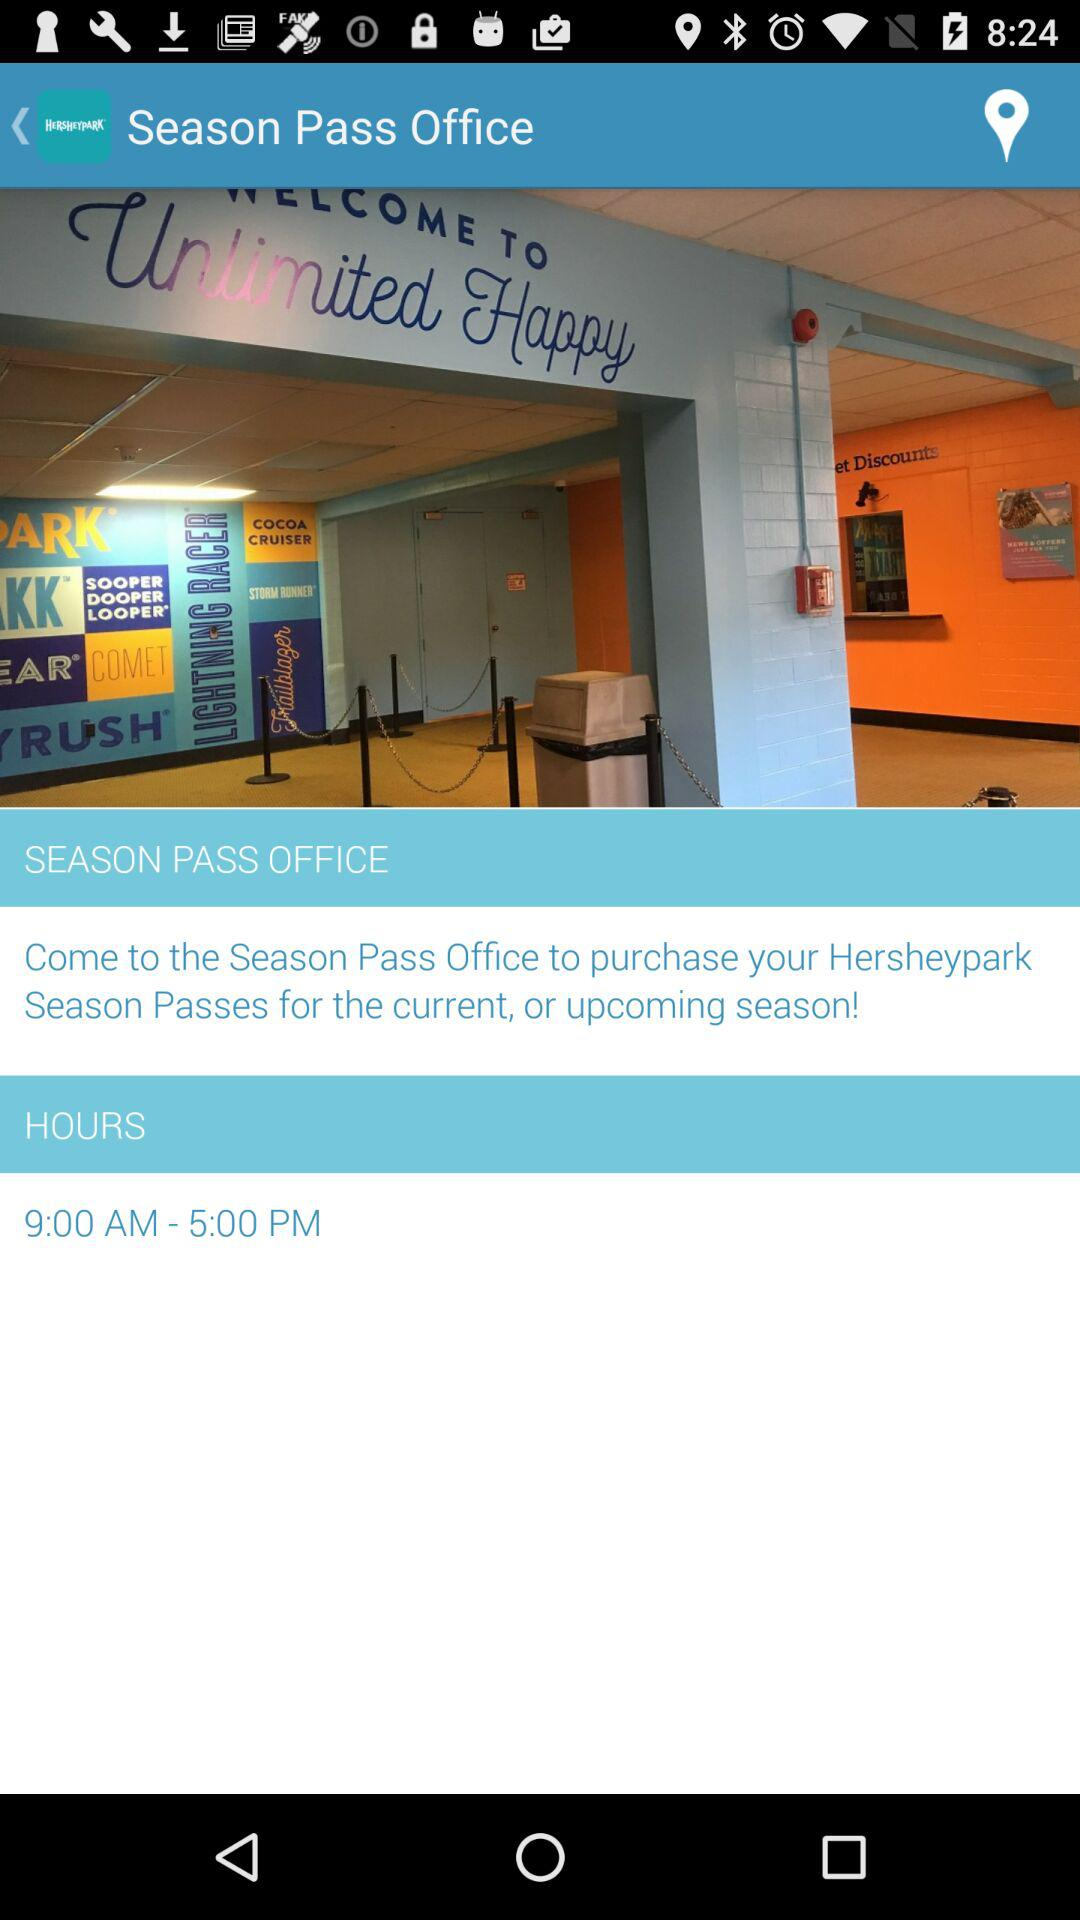What pass can we purchase from the season pass office? You can purchase Hersheypark season pass. 